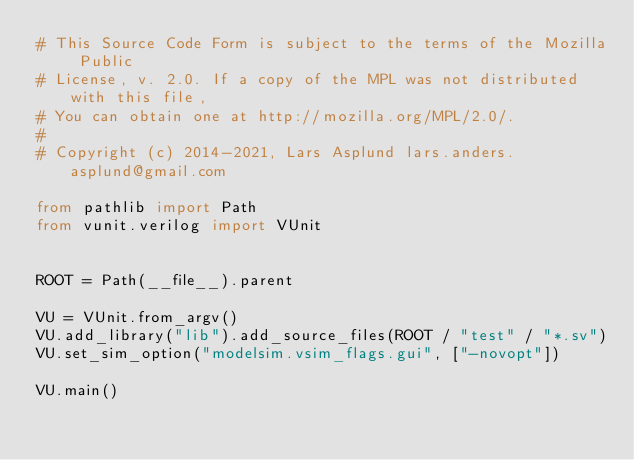Convert code to text. <code><loc_0><loc_0><loc_500><loc_500><_Python_># This Source Code Form is subject to the terms of the Mozilla Public
# License, v. 2.0. If a copy of the MPL was not distributed with this file,
# You can obtain one at http://mozilla.org/MPL/2.0/.
#
# Copyright (c) 2014-2021, Lars Asplund lars.anders.asplund@gmail.com

from pathlib import Path
from vunit.verilog import VUnit


ROOT = Path(__file__).parent

VU = VUnit.from_argv()
VU.add_library("lib").add_source_files(ROOT / "test" / "*.sv")
VU.set_sim_option("modelsim.vsim_flags.gui", ["-novopt"])

VU.main()
</code> 